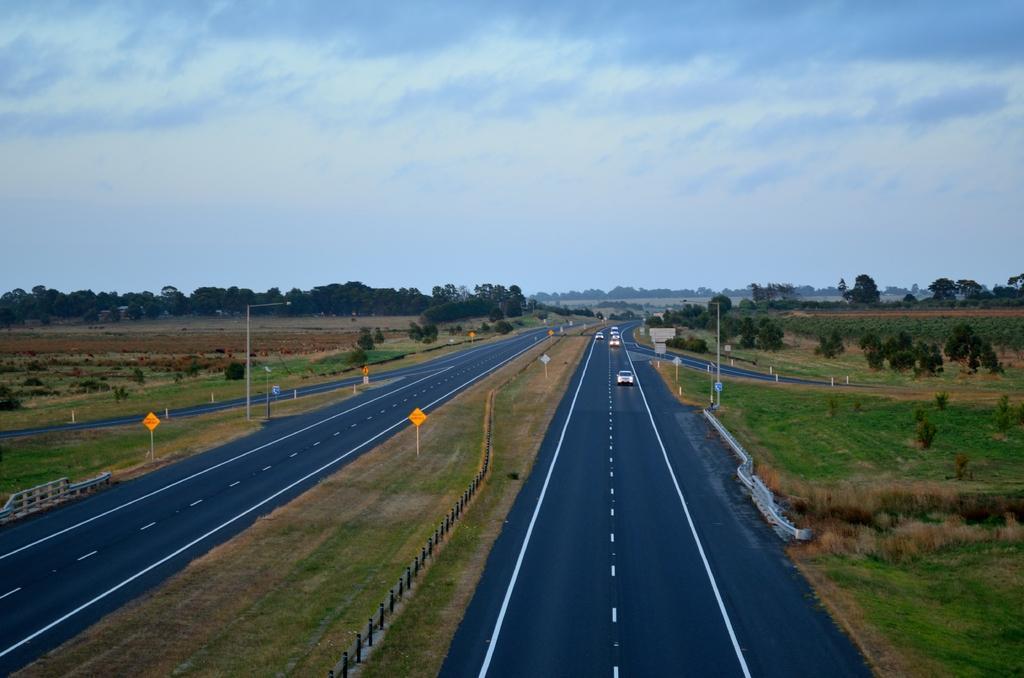Please provide a concise description of this image. In this image there are vehicles on the road, there are poles, lights, boards, plants, trees, and in the background there is sky. 